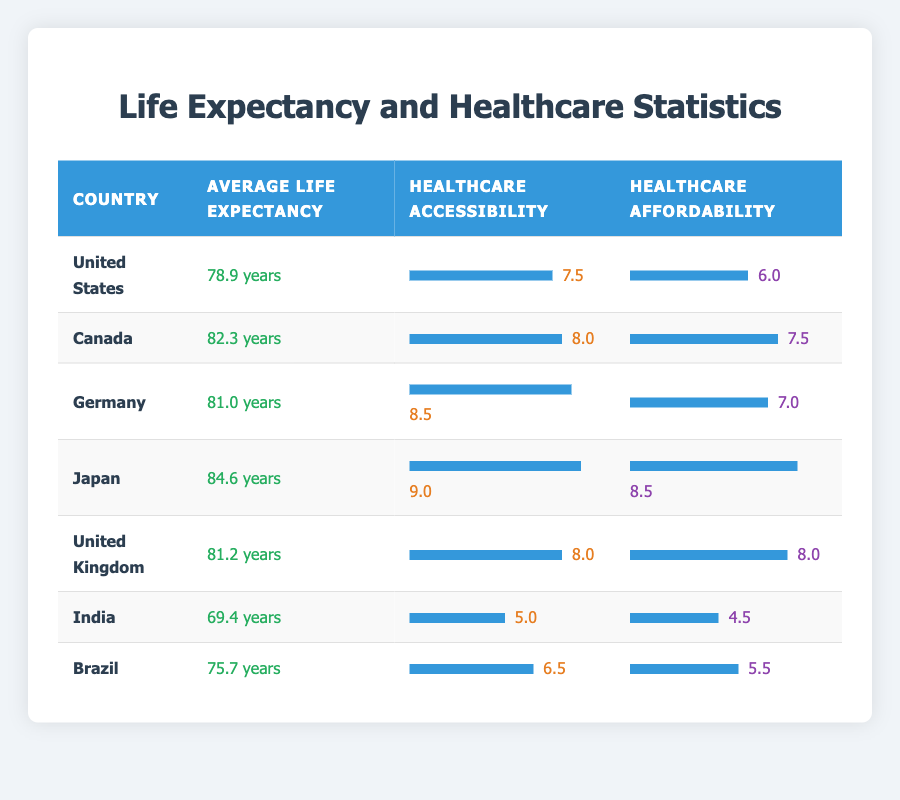What is the average life expectancy in Japan? Japan has an average life expectancy of 84.6 years, directly stated in the table.
Answer: 84.6 years Which country has the highest healthcare accessibility index? The healthcare accessibility index for each country is listed, and Japan has the highest value at 9.0.
Answer: Japan What is the combined average life expectancy of countries with a healthcare affordability index of 7 or higher? The relevant countries are Canada (82.3), Germany (81.0), Japan (84.6), United Kingdom (81.2) and those values sum to 329.1. Dividing by 4 countries gives an average of 82.275.
Answer: 82.275 years Is the average life expectancy in India higher than in Brazil? The average life expectancy in India is 69.4 years, while in Brazil it's 75.7 years, making the statement false.
Answer: No What is the difference in healthcare accessibility between Germany and India? Germany has an accessibility index of 8.5, while India has an index of 5.0. The difference is calculated as 8.5 - 5.0 = 3.5.
Answer: 3.5 Which country has an average life expectancy that is closest to the world average of 75 years? The life expectancy values close to 75 years are Brazil at 75.7 and the US at 78.9. The closest is Brazil at 75.7 years.
Answer: Brazil Does the United Kingdom have a better healthcare affordability index than the United States? The UK has an affordability index of 8.0, whereas the US has an index of 6.0, indicating that the statement is true.
Answer: Yes What is the average healthcare affordability index for all countries listed? The affordability indices are 6.0 (US), 7.5 (Canada), 7.0 (Germany), 8.5 (Japan), 8.0 (UK), 4.5 (India), 5.5 (Brazil) summing to 47.0. There are 7 countries, so the average is 47.0 / 7 = 6.71.
Answer: 6.71 